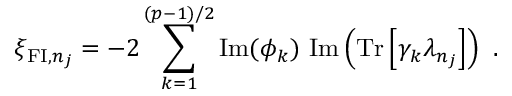Convert formula to latex. <formula><loc_0><loc_0><loc_500><loc_500>\xi _ { { F I } , n _ { j } } = - 2 \sum _ { k = 1 } ^ { ( p - 1 ) / 2 } I m ( \phi _ { k } ) I m \left ( T r \left [ \gamma _ { k } \lambda _ { n _ { j } } \right ] \right ) .</formula> 